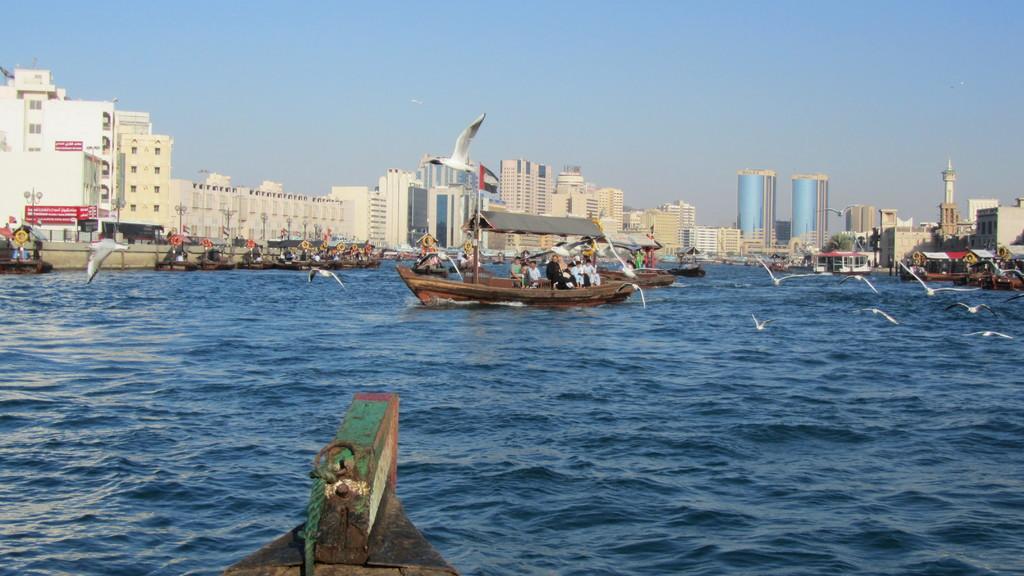In one or two sentences, can you explain what this image depicts? This image consists of boats. At the bottom, there is water. In the front, we can see birds flying in the air. In the background, there are buildings and skyscrapers. At the top, there is sky. 